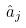<formula> <loc_0><loc_0><loc_500><loc_500>\hat { a } _ { j }</formula> 